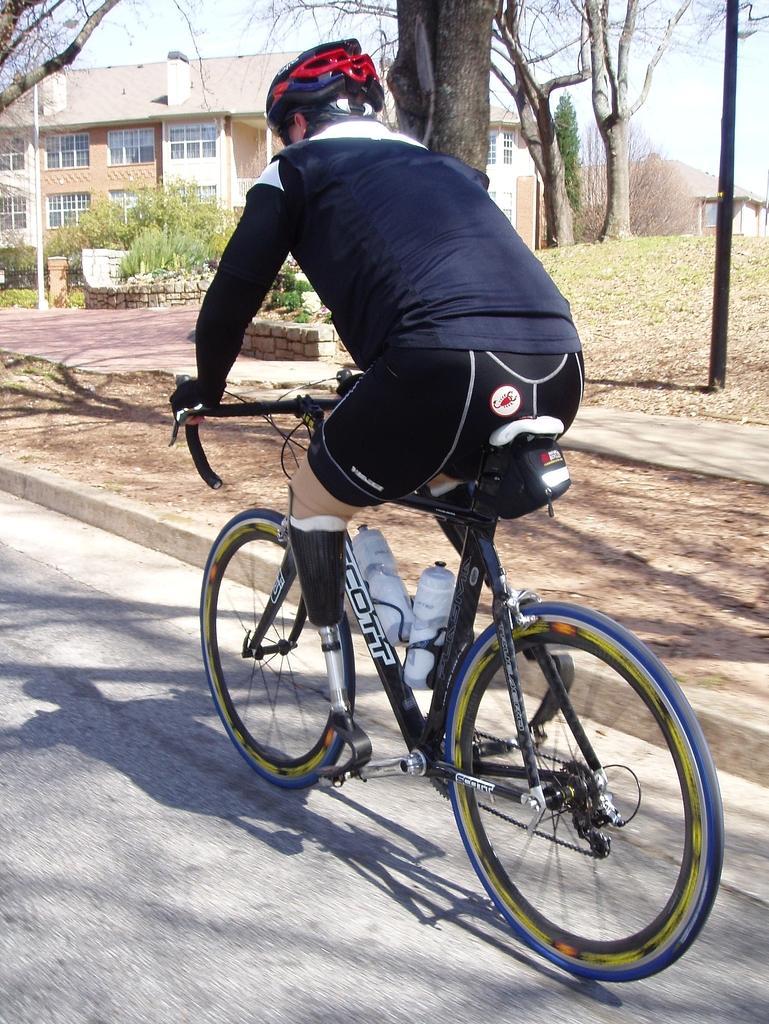Please provide a concise description of this image. In this image I can see a person riding a bicycle. There are poles, grass, trees and a building at the back. 